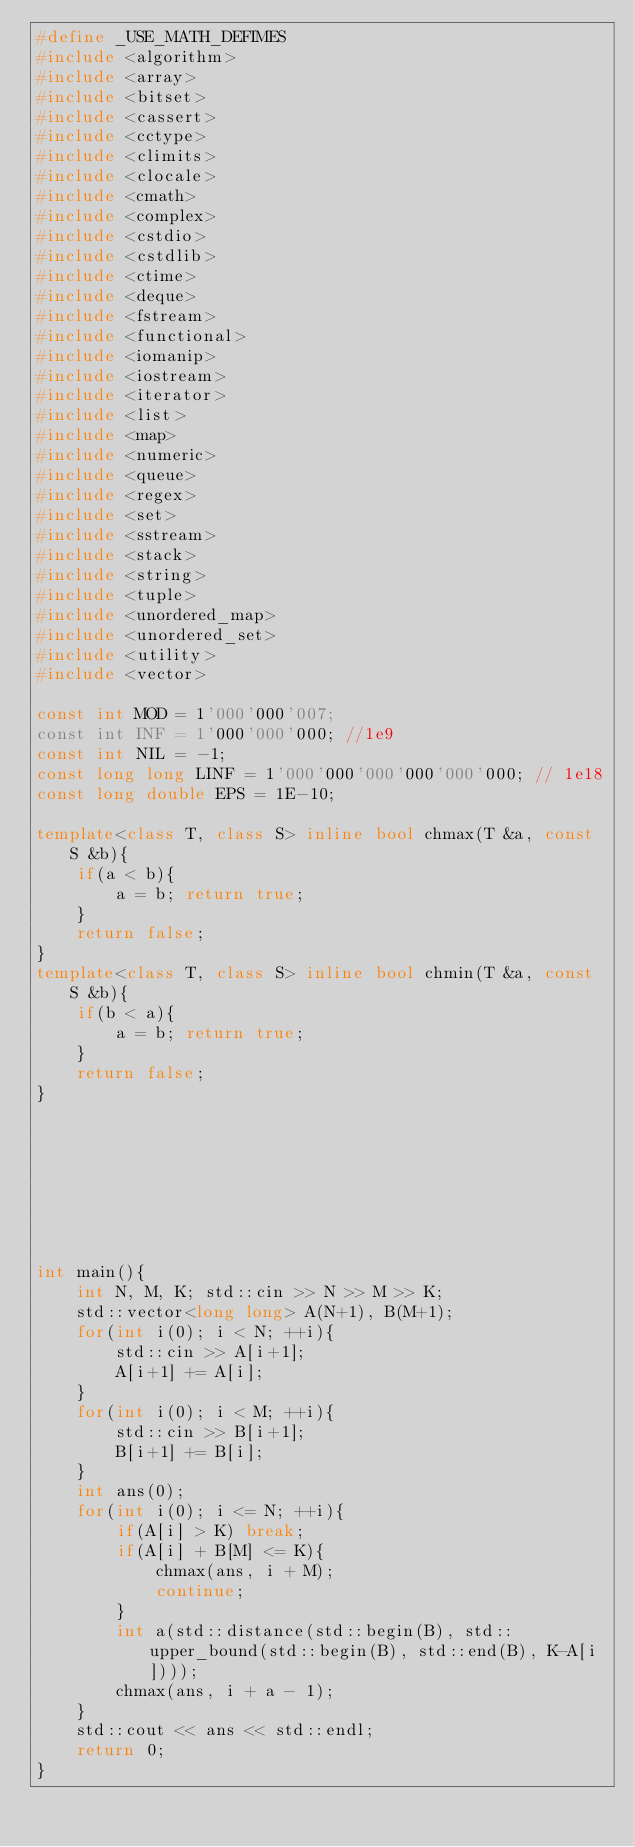Convert code to text. <code><loc_0><loc_0><loc_500><loc_500><_C++_>#define _USE_MATH_DEFIMES
#include <algorithm>
#include <array>
#include <bitset>
#include <cassert>
#include <cctype>
#include <climits>
#include <clocale>
#include <cmath>
#include <complex>
#include <cstdio>
#include <cstdlib>
#include <ctime>
#include <deque>
#include <fstream>
#include <functional>
#include <iomanip>
#include <iostream>
#include <iterator>
#include <list>
#include <map>
#include <numeric>
#include <queue>
#include <regex>
#include <set>
#include <sstream>
#include <stack>
#include <string>
#include <tuple>
#include <unordered_map>
#include <unordered_set>
#include <utility>
#include <vector>

const int MOD = 1'000'000'007;
const int INF = 1'000'000'000; //1e9
const int NIL = -1;
const long long LINF = 1'000'000'000'000'000'000; // 1e18
const long double EPS = 1E-10;

template<class T, class S> inline bool chmax(T &a, const S &b){
    if(a < b){
        a = b; return true;
    }
    return false;
}
template<class T, class S> inline bool chmin(T &a, const S &b){
    if(b < a){
        a = b; return true;
    }
    return false;
}








int main(){
    int N, M, K; std::cin >> N >> M >> K;
    std::vector<long long> A(N+1), B(M+1);
    for(int i(0); i < N; ++i){
        std::cin >> A[i+1];
        A[i+1] += A[i];
    }
    for(int i(0); i < M; ++i){
        std::cin >> B[i+1];
        B[i+1] += B[i];
    }
    int ans(0);
    for(int i(0); i <= N; ++i){
        if(A[i] > K) break;
        if(A[i] + B[M] <= K){
            chmax(ans, i + M);
            continue;
        }
        int a(std::distance(std::begin(B), std::upper_bound(std::begin(B), std::end(B), K-A[i])));
        chmax(ans, i + a - 1);
    }
    std::cout << ans << std::endl;
    return 0;
}
</code> 